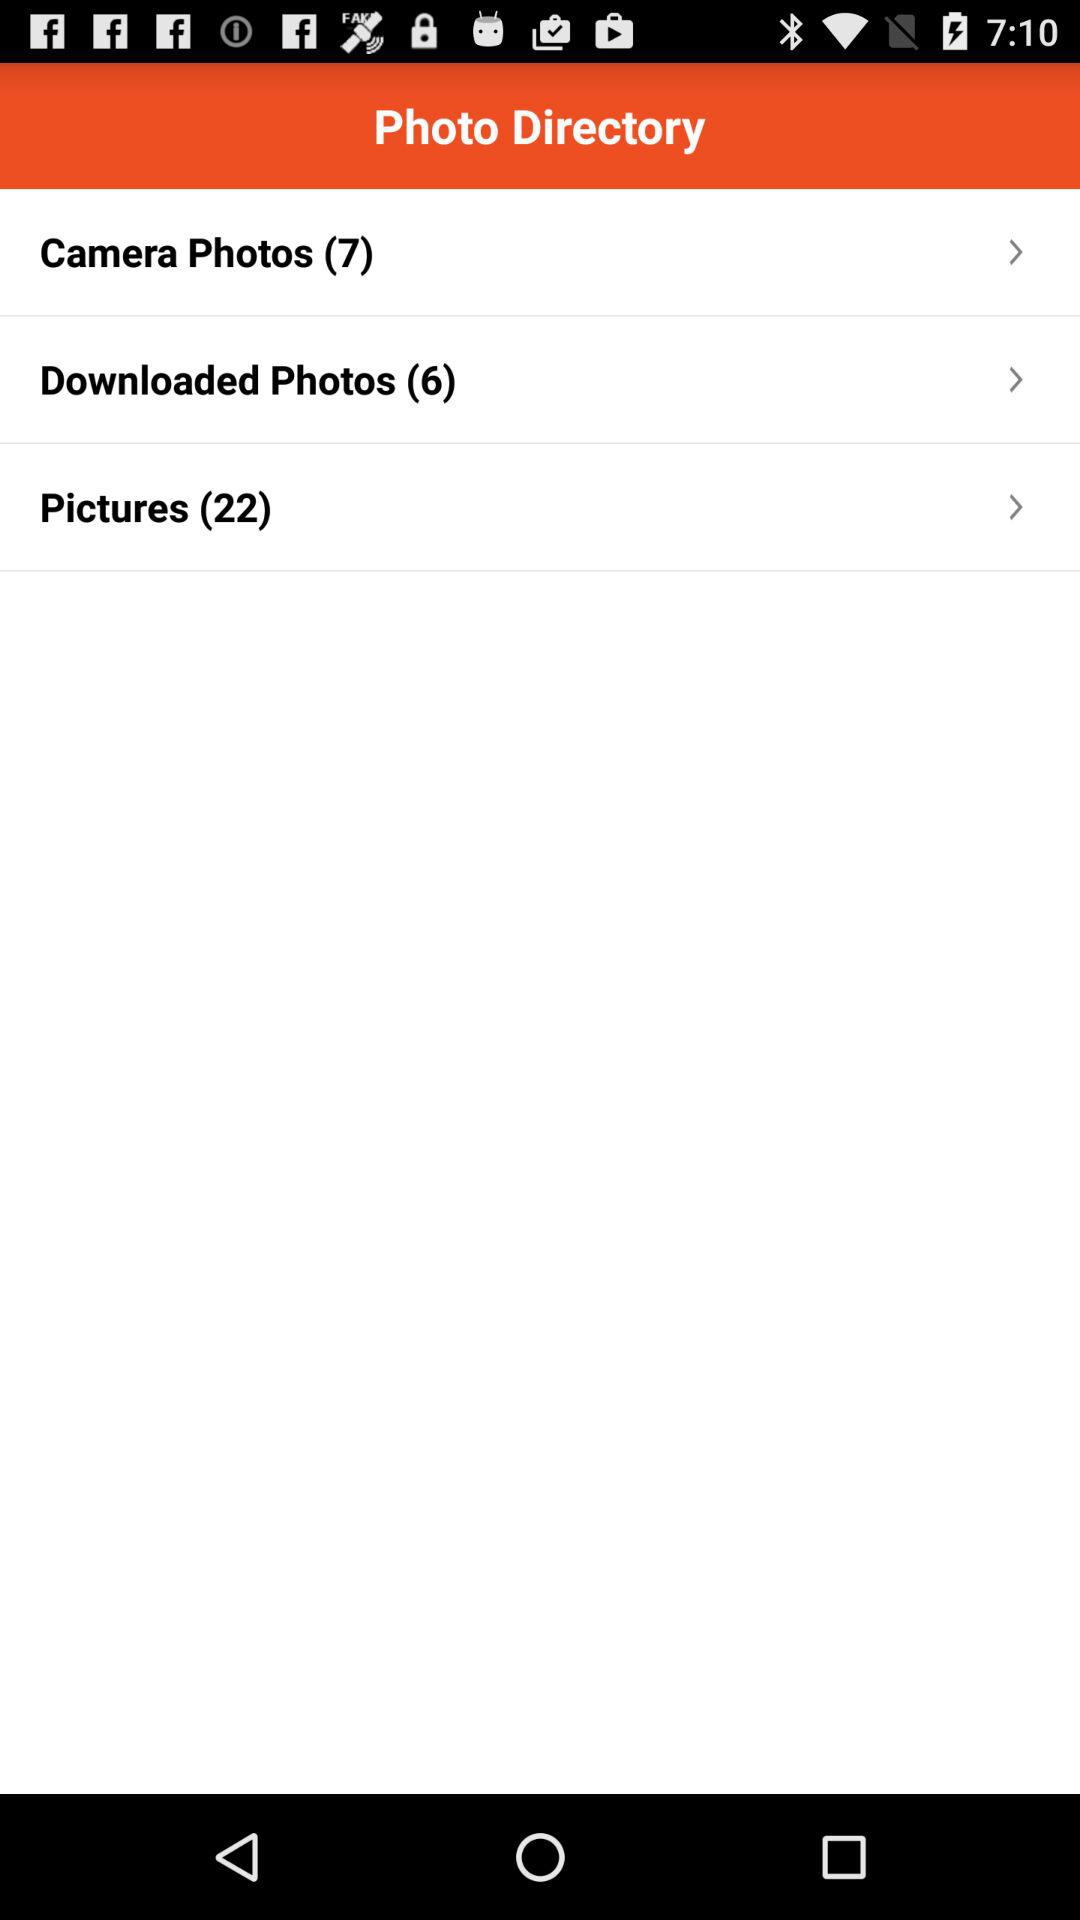How many more photos are in the Pictures folder than in the Camera Photos folder?
Answer the question using a single word or phrase. 15 